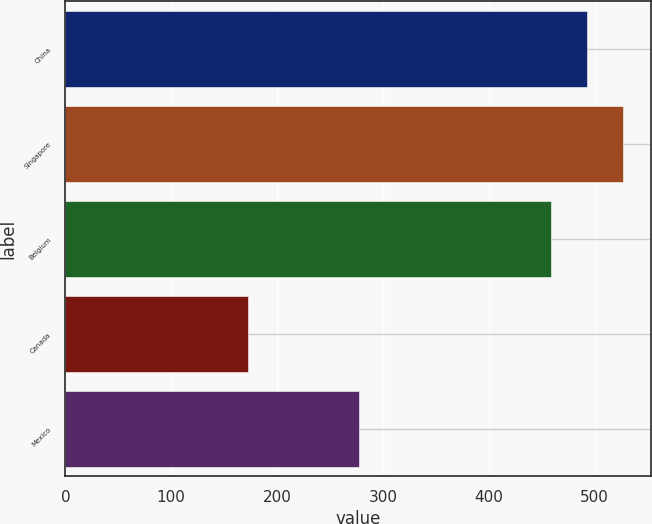<chart> <loc_0><loc_0><loc_500><loc_500><bar_chart><fcel>China<fcel>Singapore<fcel>Belgium<fcel>Canada<fcel>Mexico<nl><fcel>493<fcel>527<fcel>459<fcel>173<fcel>277<nl></chart> 